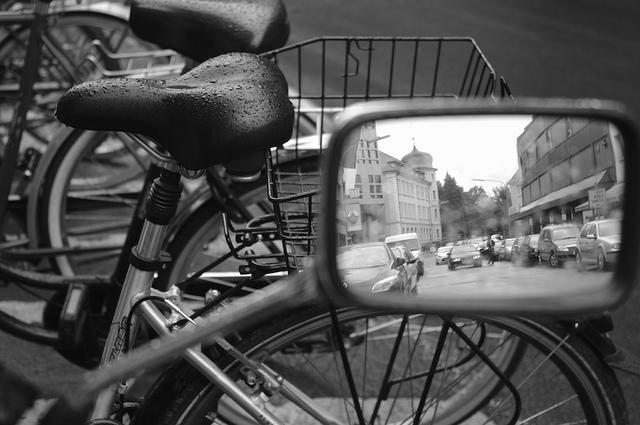Why is the black bike seat wet? Please explain your reasoning. rain. It is outdoors in a cityscape, under a gloomy sky with no person, sea, or other liquids in sight. 